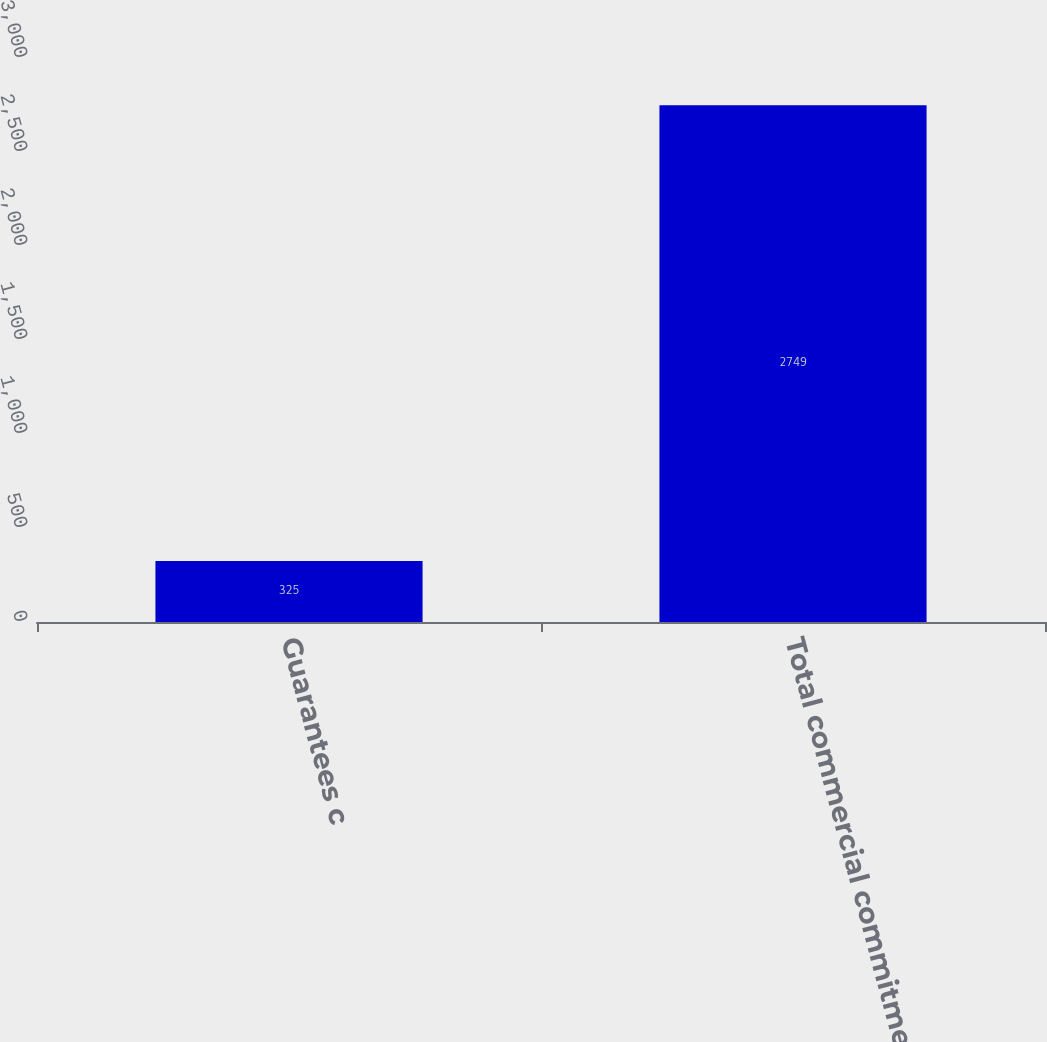<chart> <loc_0><loc_0><loc_500><loc_500><bar_chart><fcel>Guarantees c<fcel>Total commercial commitments<nl><fcel>325<fcel>2749<nl></chart> 